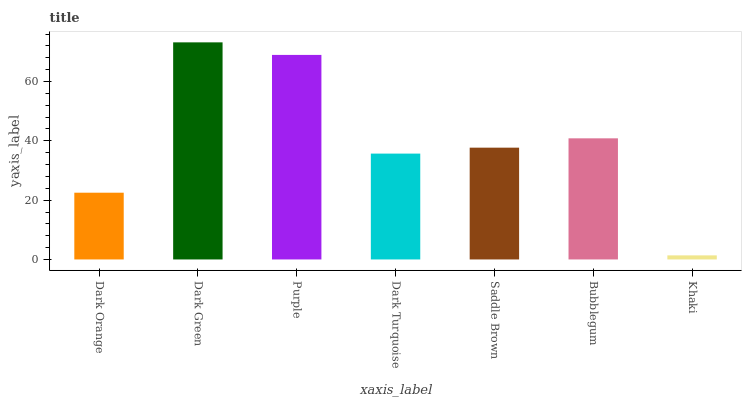Is Khaki the minimum?
Answer yes or no. Yes. Is Dark Green the maximum?
Answer yes or no. Yes. Is Purple the minimum?
Answer yes or no. No. Is Purple the maximum?
Answer yes or no. No. Is Dark Green greater than Purple?
Answer yes or no. Yes. Is Purple less than Dark Green?
Answer yes or no. Yes. Is Purple greater than Dark Green?
Answer yes or no. No. Is Dark Green less than Purple?
Answer yes or no. No. Is Saddle Brown the high median?
Answer yes or no. Yes. Is Saddle Brown the low median?
Answer yes or no. Yes. Is Dark Green the high median?
Answer yes or no. No. Is Dark Green the low median?
Answer yes or no. No. 